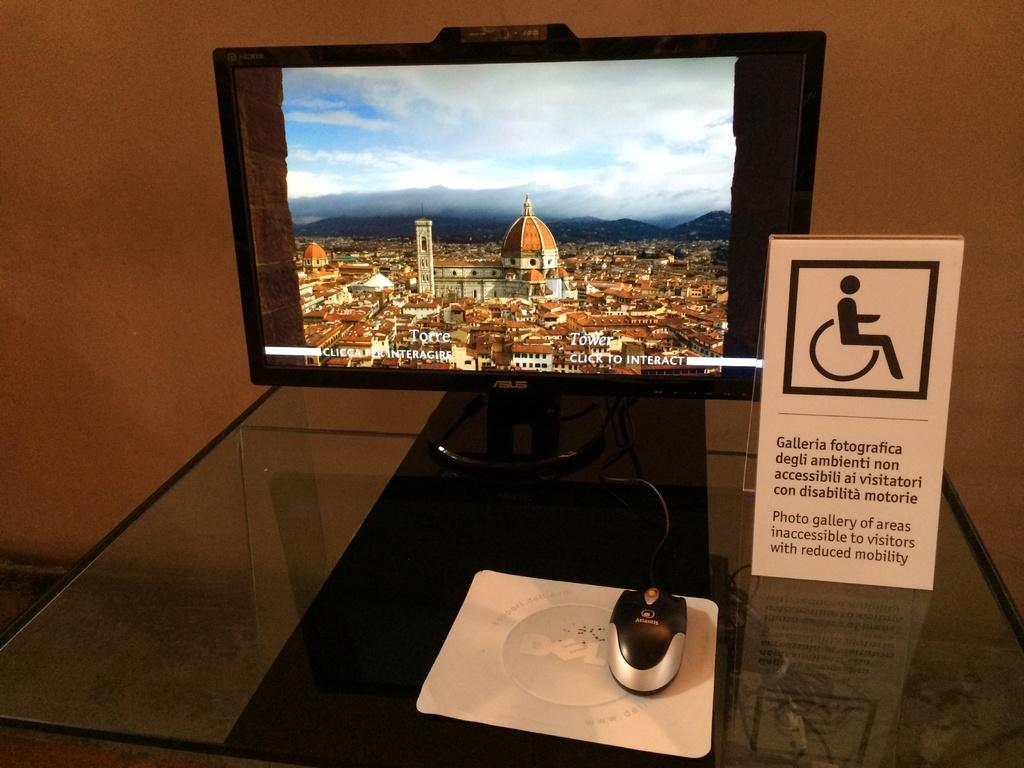<image>
Write a terse but informative summary of the picture. A computer monitor displays a Torre Tower image and suggests clicking to interact. 